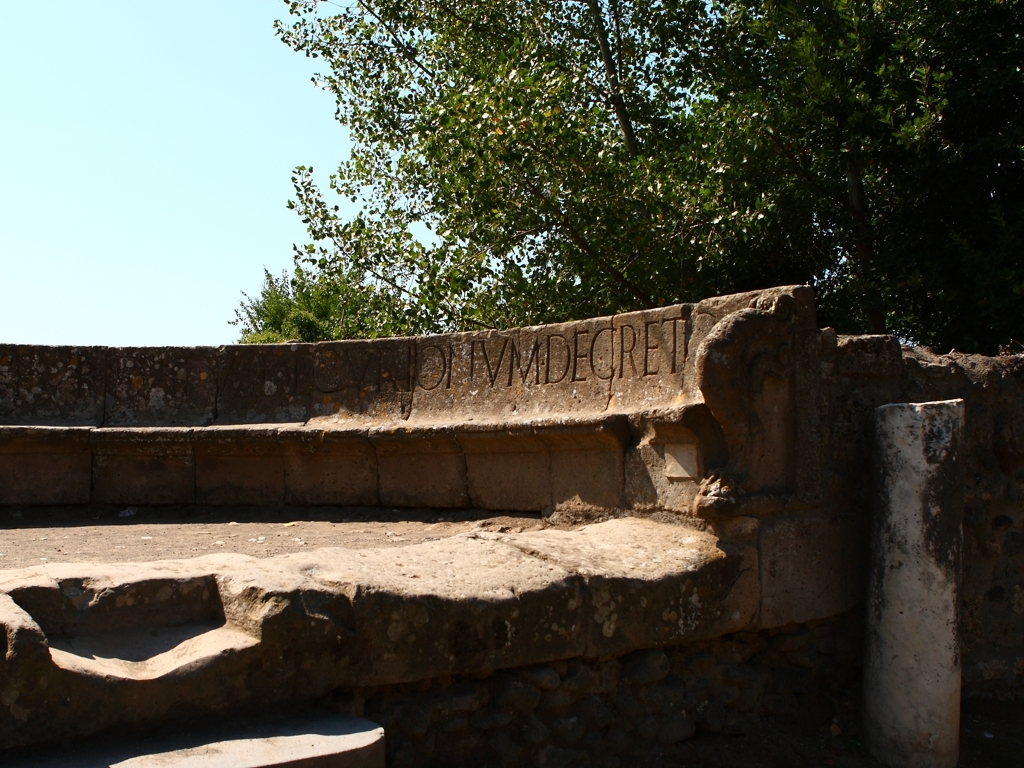Can you tell me what the inscription on the stone might signify? The inscription is carved in an elegant script, suggesting that it could be a significant phrase or a dedication. Often, such inscriptions refer to historical events, figures, or cultural expressions pertinent to the time and region it originates from. To understand its full significance, the inscription would need to be translated and studied within its archaeological context. What can you infer about the culture or time period from this image? The architectural style, including the use of stone and the particular form of the inscribed letters, points to a construction that could be from the ancient Roman or Greek period. Such ruins often reflect a society that valued public works, had a penchant for durable construction, and engaged in inscribing monuments with important texts that range from laws, decrees, to commemorations of significant events. 